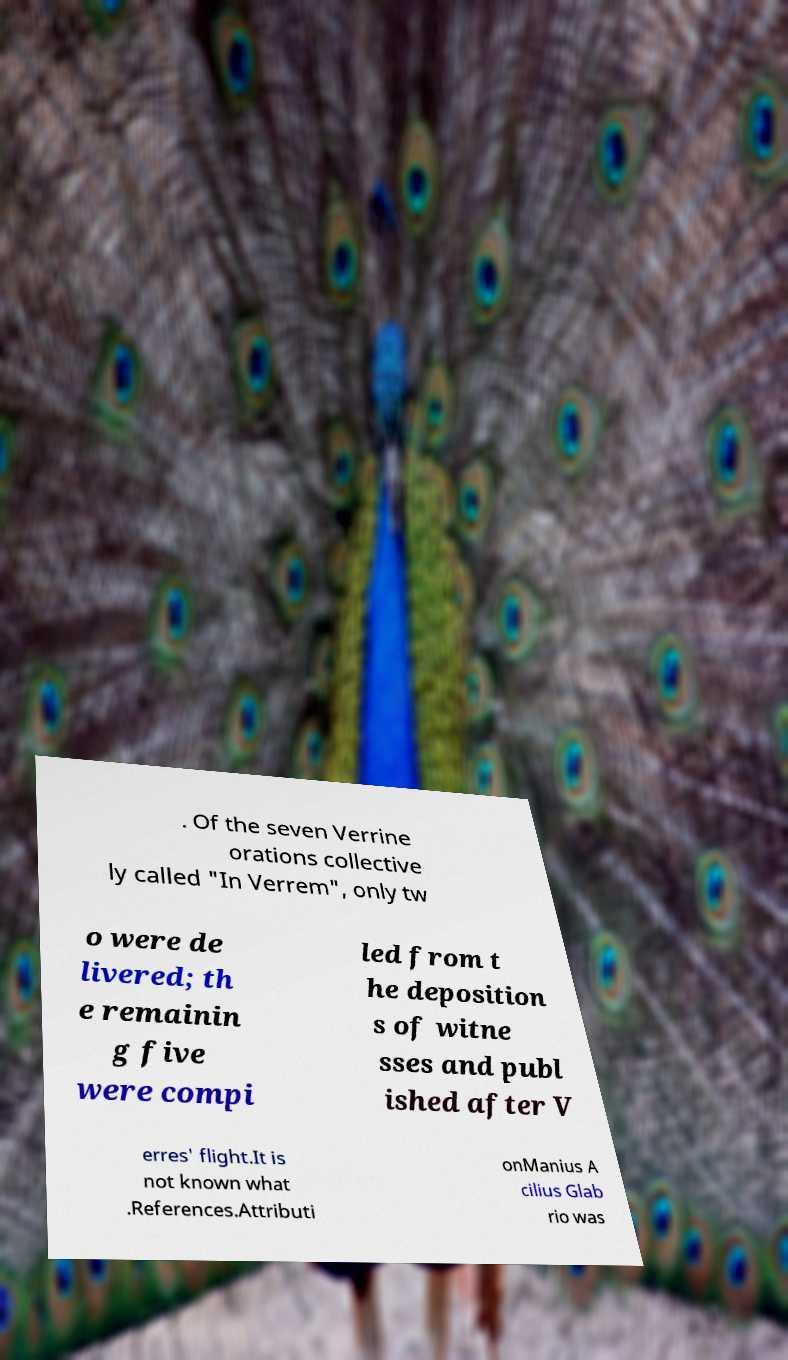There's text embedded in this image that I need extracted. Can you transcribe it verbatim? . Of the seven Verrine orations collective ly called "In Verrem", only tw o were de livered; th e remainin g five were compi led from t he deposition s of witne sses and publ ished after V erres' flight.It is not known what .References.Attributi onManius A cilius Glab rio was 